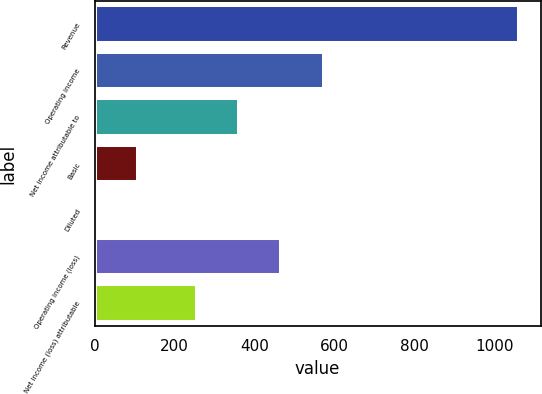Convert chart. <chart><loc_0><loc_0><loc_500><loc_500><bar_chart><fcel>Revenue<fcel>Operating income<fcel>Net income attributable to<fcel>Basic<fcel>Diluted<fcel>Operating income (loss)<fcel>Net income (loss) attributable<nl><fcel>1062.9<fcel>573.69<fcel>361.43<fcel>107.76<fcel>1.63<fcel>467.56<fcel>255.3<nl></chart> 